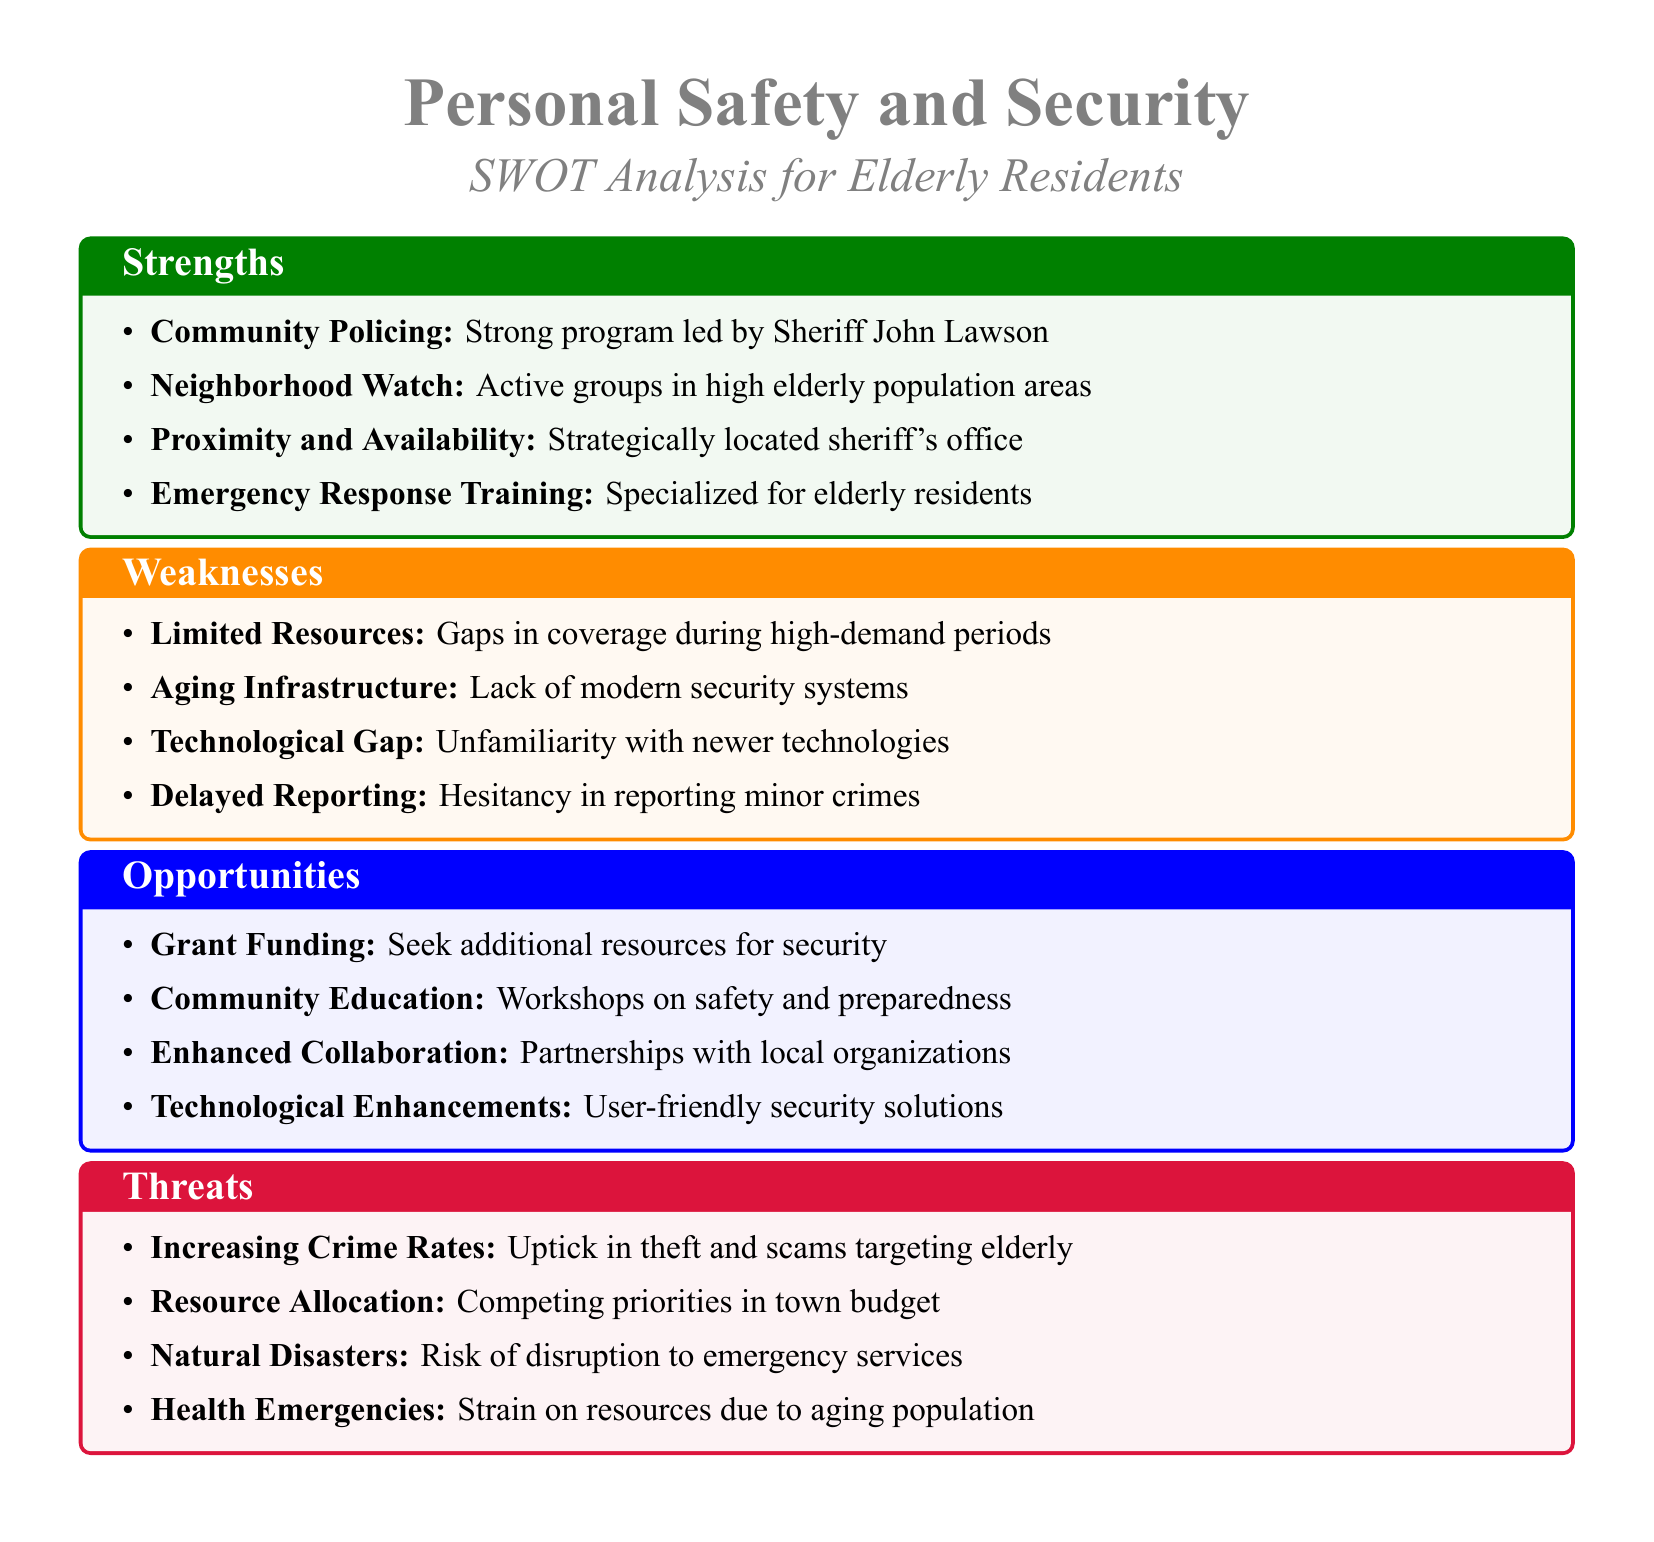What is the name of the sheriff? The document specifically names the sheriff as John Lawson, highlighting his leadership role in community policing.
Answer: John Lawson How many strengths are listed in the analysis? The analysis lists four strengths related to personal safety and security for elderly residents.
Answer: 4 What is one weakness identified regarding personal safety? One documented weakness points to "Limited Resources" which indicates gaps in coverage during peak demand times.
Answer: Limited Resources What is one opportunity for enhancing safety measures? An opportunity mentioned is "Grant Funding," which suggests seeking additional resources for security enhancements.
Answer: Grant Funding What threat increases crime rates for the elderly? The document indicates "Increasing Crime Rates" as a notable threat, specifically citing a rise in theft and scams targeting elderly individuals.
Answer: Increasing Crime Rates What community program is highlighted as a strength? The strength of "Neighborhood Watch" is emphasized as actively involving groups in areas with a high elderly population.
Answer: Neighborhood Watch What is one form of collaboration suggested in the opportunities? The analysis proposes "Enhanced Collaboration" as a way to work better with local organizations for safety initiatives.
Answer: Enhanced Collaboration What is a weakness related to technology? The document identifies "Technological Gap," referring to the elderly's unfamiliarity with newer technologies as a significant weakness.
Answer: Technological Gap 